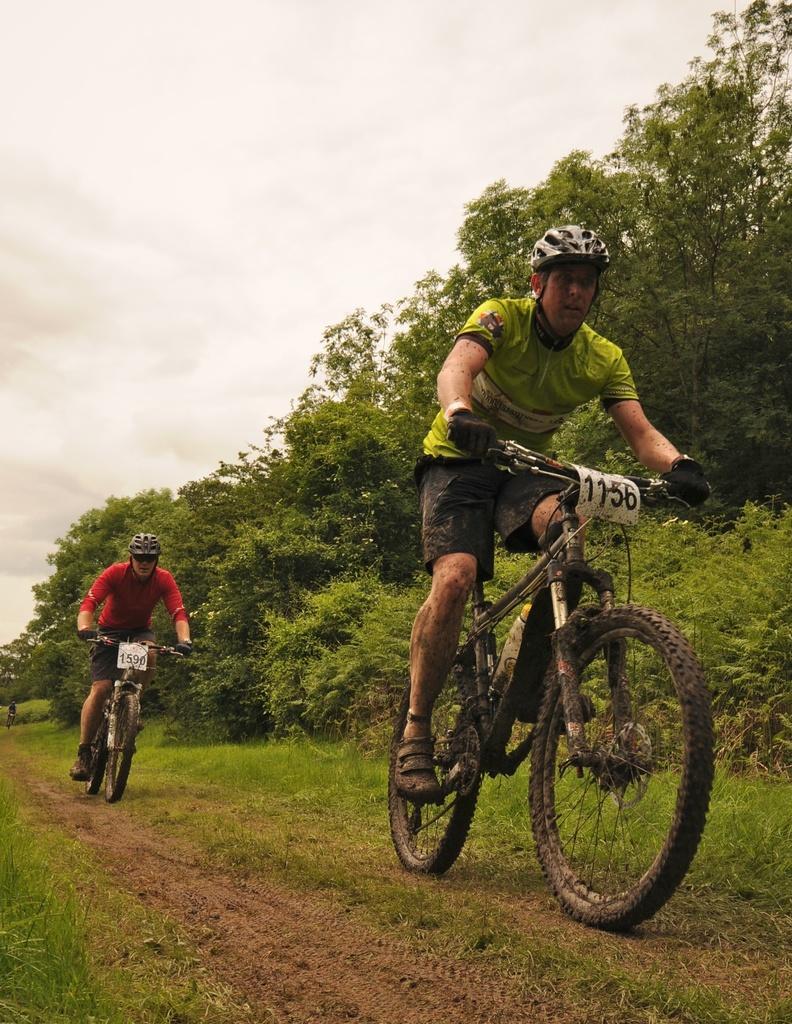Please provide a concise description of this image. Here we see two men riding bicycle and we can see cloudy sky and trees. 